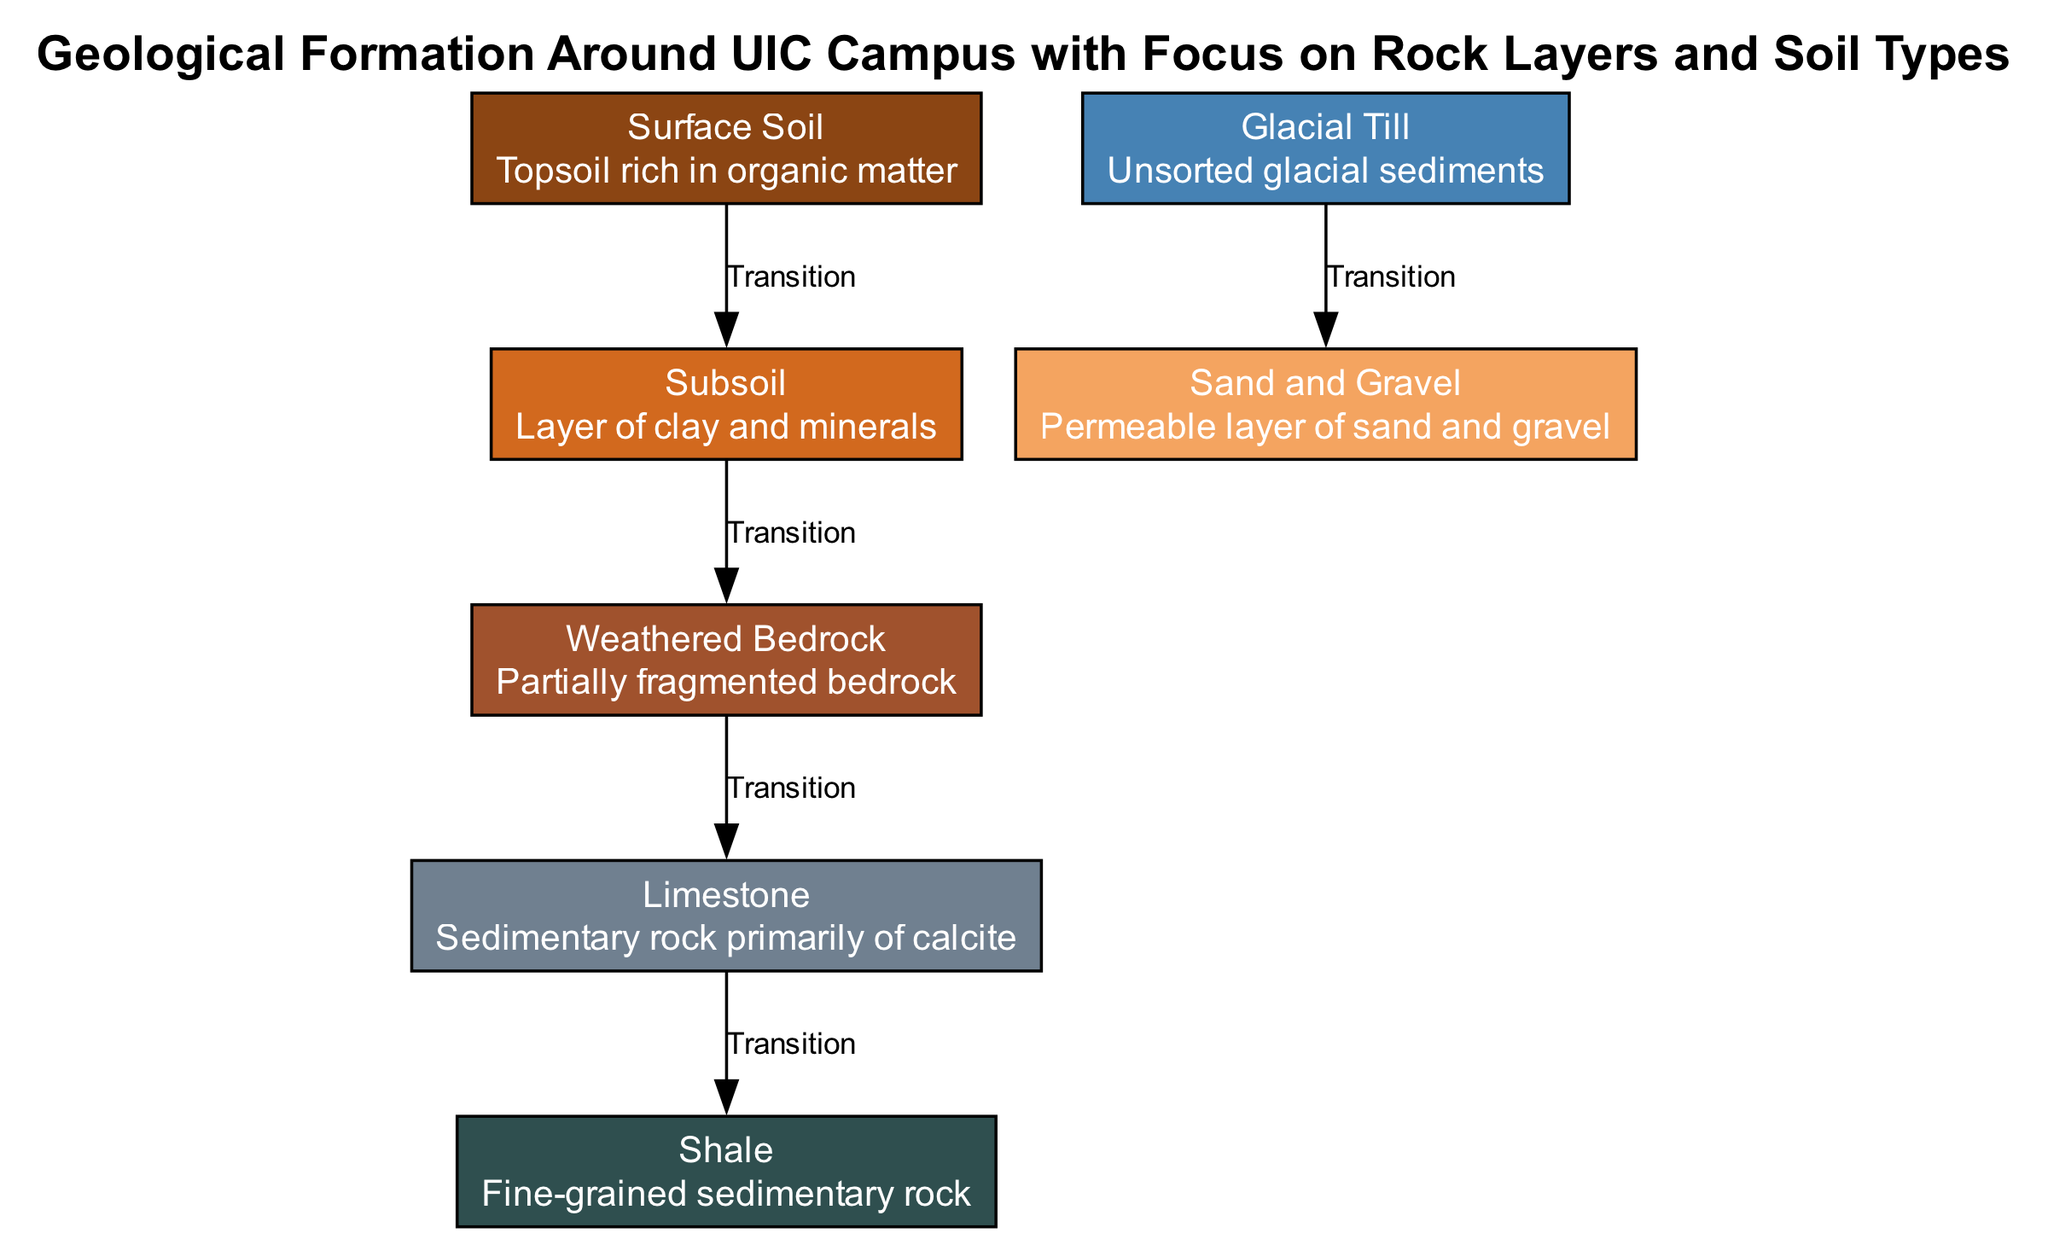What is the top layer of soil called? The diagram indicates that the top layer of soil is labeled as "Surface Soil." This is directly mentioned in the description of the first node listed in the diagram.
Answer: Surface Soil How many layers transition directly below the surface soil? The diagram shows that there is one transition directly below the "Surface Soil," leading to the "Subsoil." This is illustrated by a single edge connecting these two nodes.
Answer: One What type of rock is indicated as primarily composed of calcite? Referring to the node labeled "Limestone," the description specifies that it is a sedimentary rock primarily made up of calcite. This is a direct statement found within the corresponding node.
Answer: Limestone Which layer follows the weathered bedrock? According to the edges in the diagram, the layer that follows "Weathered Bedrock" is "Limestone." This is determined by following the transition edges from one node to the next in the specified order.
Answer: Limestone What color represents the glacial till in the diagram? The color representation for "Glacial Till" is derived from the color coding defined in the diagram, which uses SteelBlue. This color coding is directly attributed to the node corresponding to glacial till.
Answer: SteelBlue How many total nodes are present in the diagram? The diagram lists a total of seven distinct nodes, as evidenced by counting each node present in the provided data.
Answer: Seven Which layer is classified as a permeable layer in the diagram? The "Sand and Gravel" layer is identified in the description as a permeable layer. This classification is specified in the information pertaining to that particular node.
Answer: Sand and Gravel What are the two types of sedimentary rock mentioned in the diagram? The two types of sedimentary rock indicated in the diagram are "Limestone" and "Shale". This is found under two separate nodes, each clearly labeled.
Answer: Limestone and Shale What is the material found directly beneath glacial till? The diagram indicates that "Sand and Gravel" is the material found directly beneath "Glacial Till," as indicated by the edge connecting these two nodes in the downward transition.
Answer: Sand and Gravel 